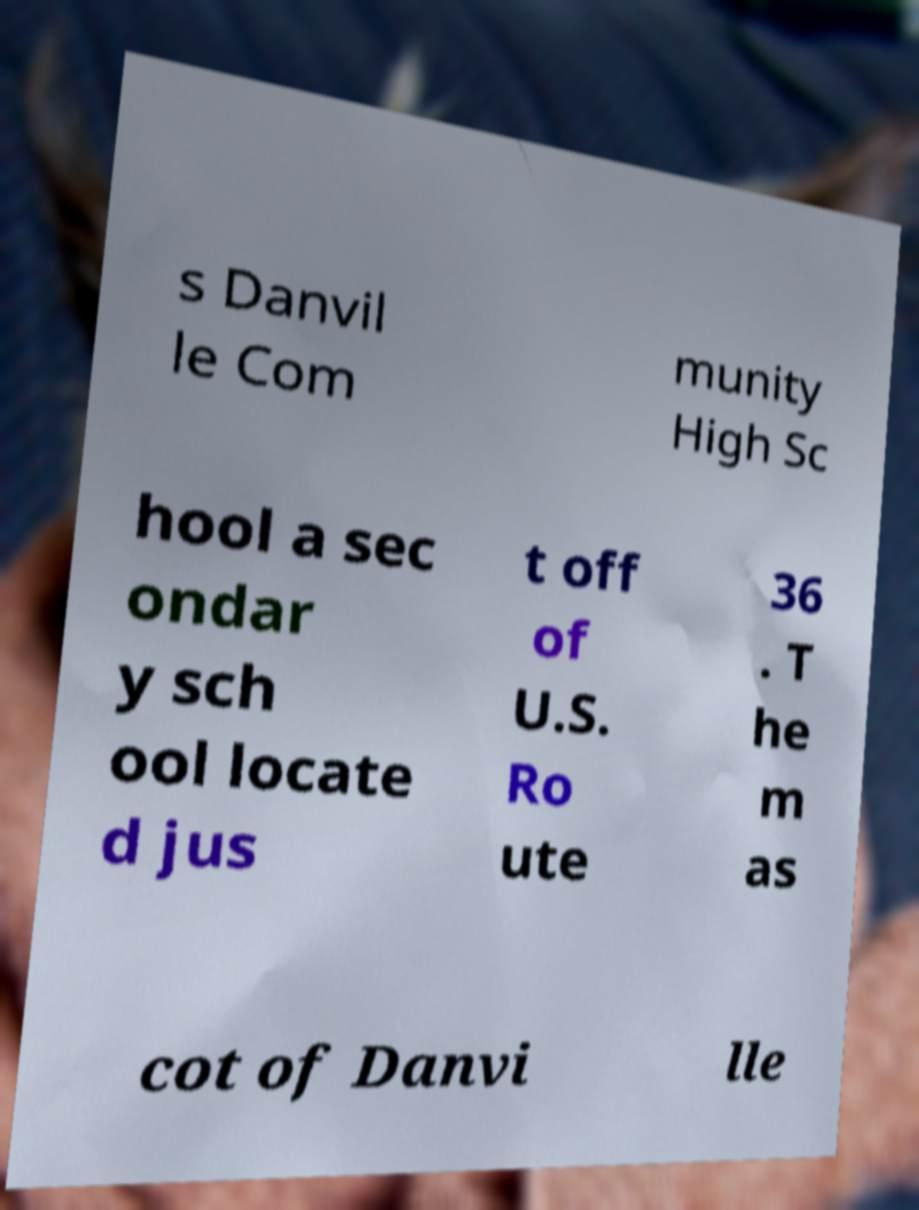What messages or text are displayed in this image? I need them in a readable, typed format. s Danvil le Com munity High Sc hool a sec ondar y sch ool locate d jus t off of U.S. Ro ute 36 . T he m as cot of Danvi lle 